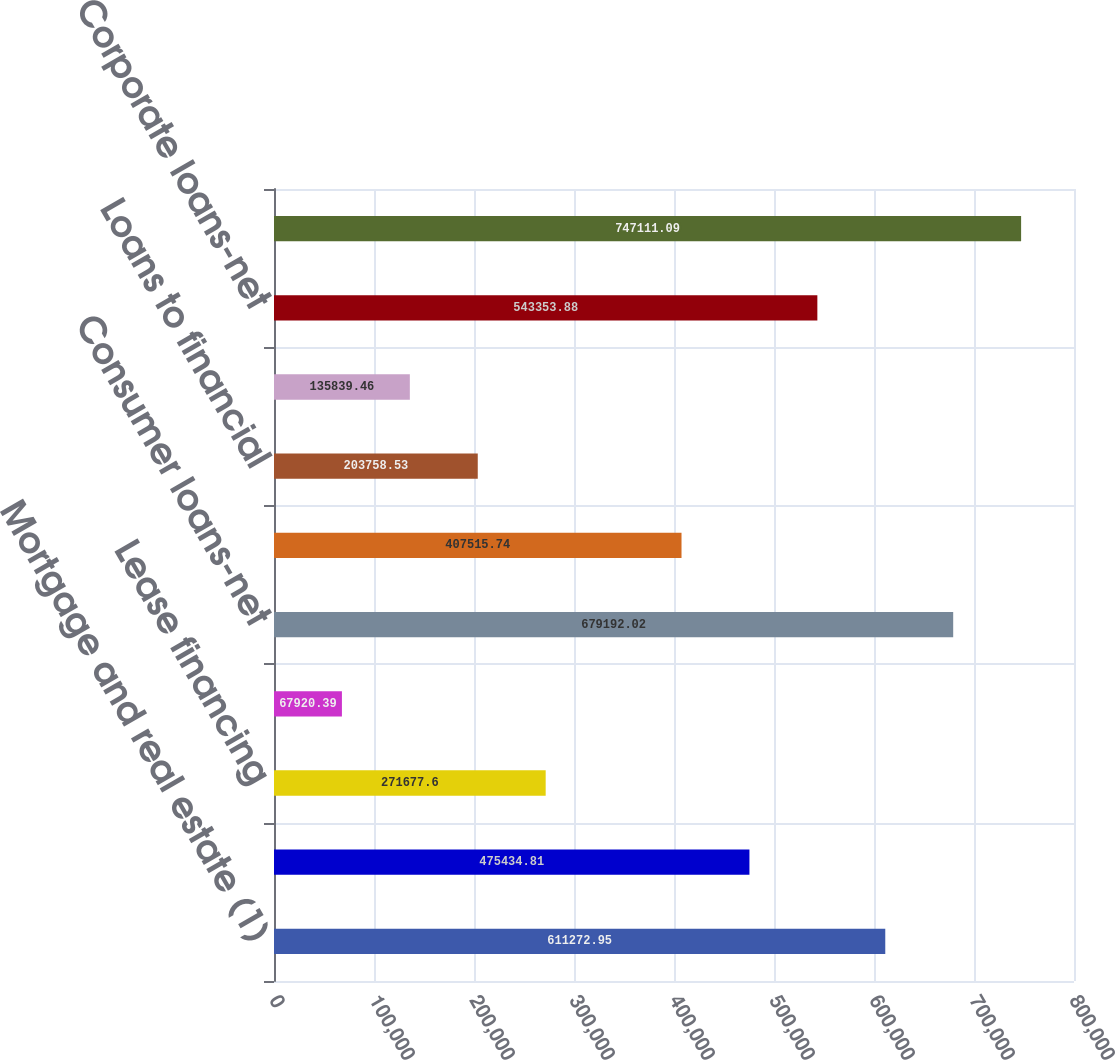Convert chart to OTSL. <chart><loc_0><loc_0><loc_500><loc_500><bar_chart><fcel>Mortgage and real estate (1)<fcel>Installment revolving credit<fcel>Lease financing<fcel>Unearned income<fcel>Consumer loans-net<fcel>Commercial and industrial<fcel>Loans to financial<fcel>Governments and official<fcel>Corporate loans-net<fcel>Total loans-net of unearned<nl><fcel>611273<fcel>475435<fcel>271678<fcel>67920.4<fcel>679192<fcel>407516<fcel>203759<fcel>135839<fcel>543354<fcel>747111<nl></chart> 